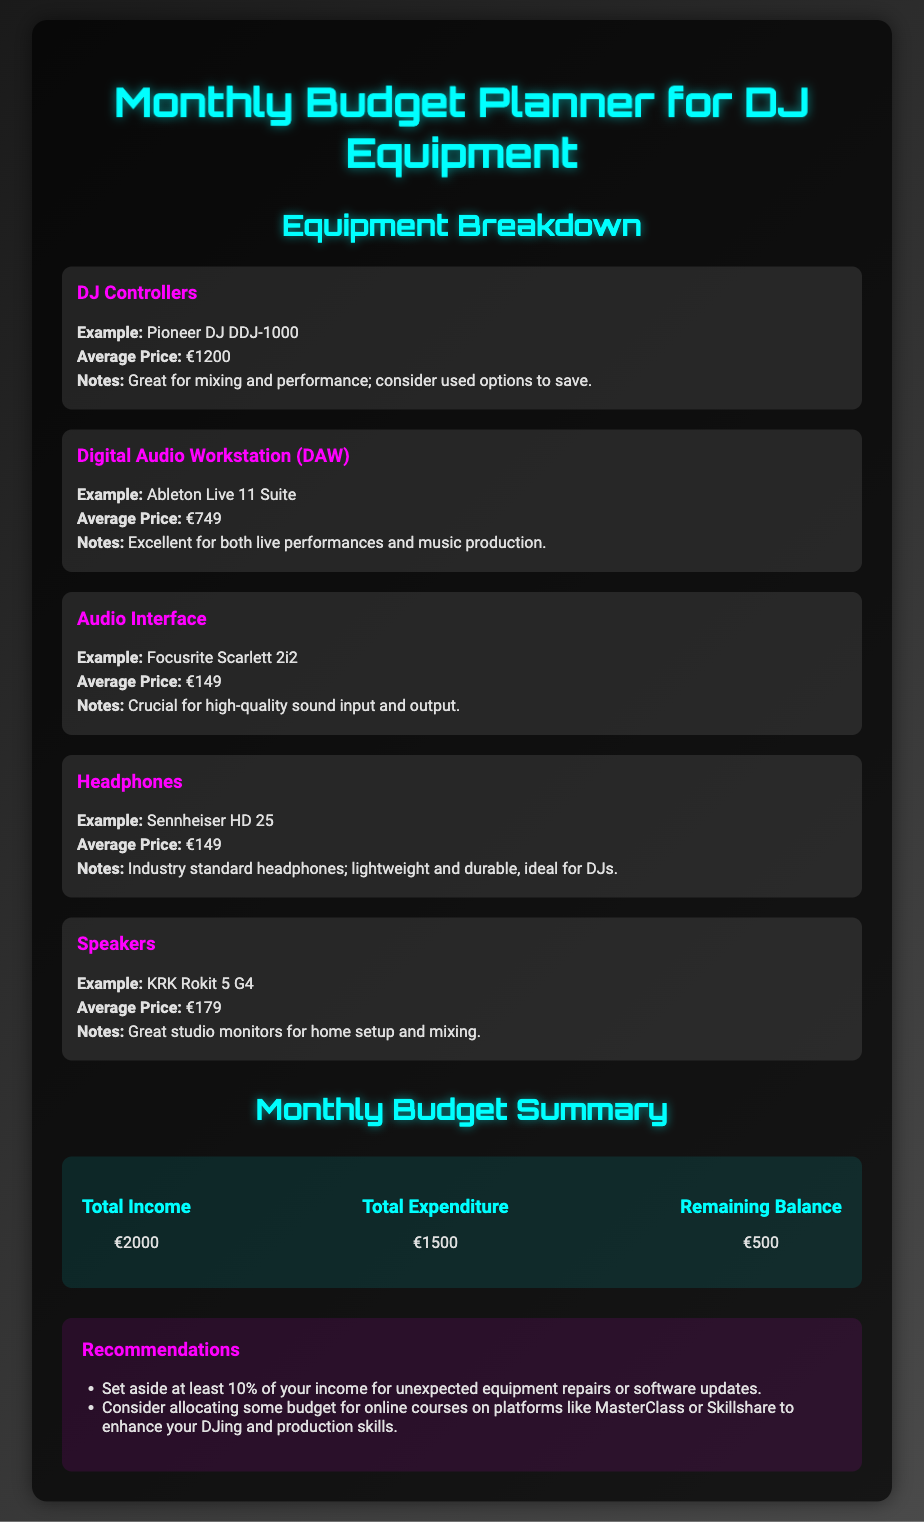What is the average price of a DJ controller? The average price is listed under the DJ Controllers section in the document.
Answer: €1200 What is the total income for the month? The total income is located in the Monthly Budget Summary section of the document.
Answer: €2000 What is recommended to enhance DJing skills? The recommendations suggest considering online courses for skill enhancement.
Answer: Online courses What is the average price of the audio interface? Information on the average price of the audio interface is provided within its respective budget item.
Answer: €149 How much is the remaining balance? The remaining balance is calculated from the total income and total expenditure shown in the budget summary.
Answer: €500 What is the example DAW mentioned? The document provides an example of a DAW under its budget item.
Answer: Ableton Live 11 Suite What percentage of income is suggested to be set aside for repairs? Recommendations indicate a specific percentage to save for repairs or updates in the document.
Answer: 10% What is the cost of the headphones listed? The cost of the headphones is specified in the respective budget item.
Answer: €149 What brand of speakers is suggested? The specific brand of speakers is mentioned in the budget item for speakers in the document.
Answer: KRK Rokit 5 G4 